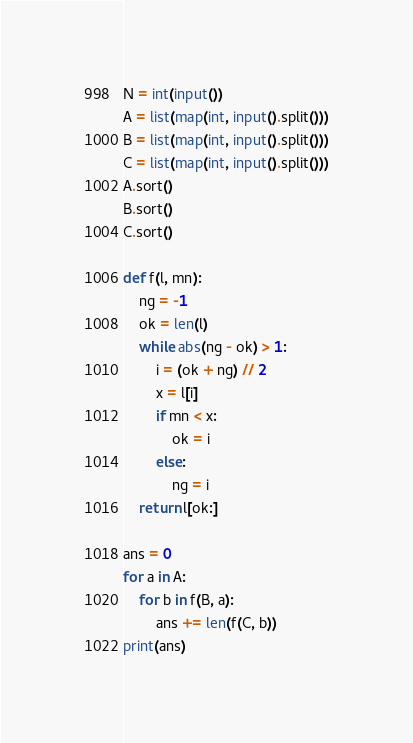Convert code to text. <code><loc_0><loc_0><loc_500><loc_500><_Python_>N = int(input())
A = list(map(int, input().split()))
B = list(map(int, input().split()))
C = list(map(int, input().split()))
A.sort()
B.sort()
C.sort()

def f(l, mn):
    ng = -1
    ok = len(l)
    while abs(ng - ok) > 1:
        i = (ok + ng) // 2
        x = l[i]
        if mn < x:
            ok = i
        else:
            ng = i
    return l[ok:]

ans = 0
for a in A:
    for b in f(B, a):
        ans += len(f(C, b))
print(ans)</code> 